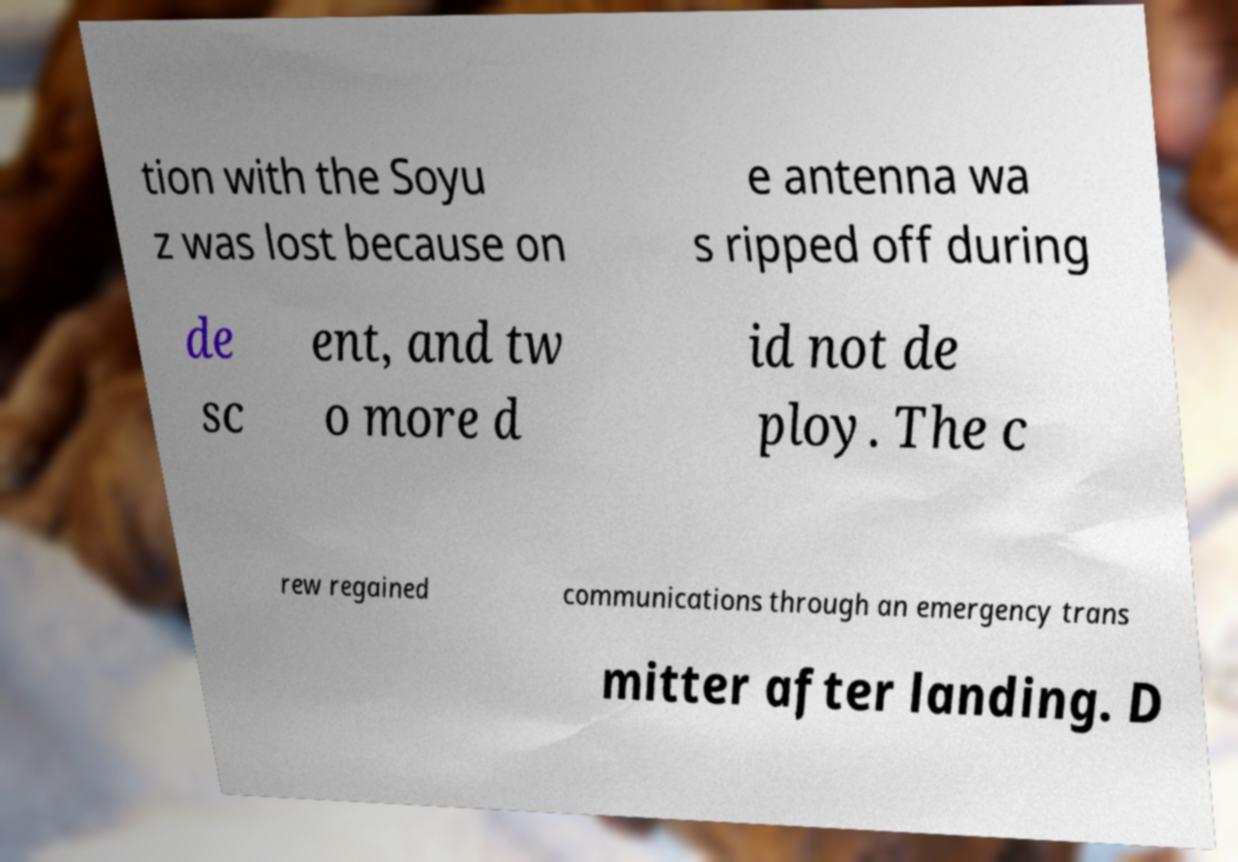Please read and relay the text visible in this image. What does it say? tion with the Soyu z was lost because on e antenna wa s ripped off during de sc ent, and tw o more d id not de ploy. The c rew regained communications through an emergency trans mitter after landing. D 